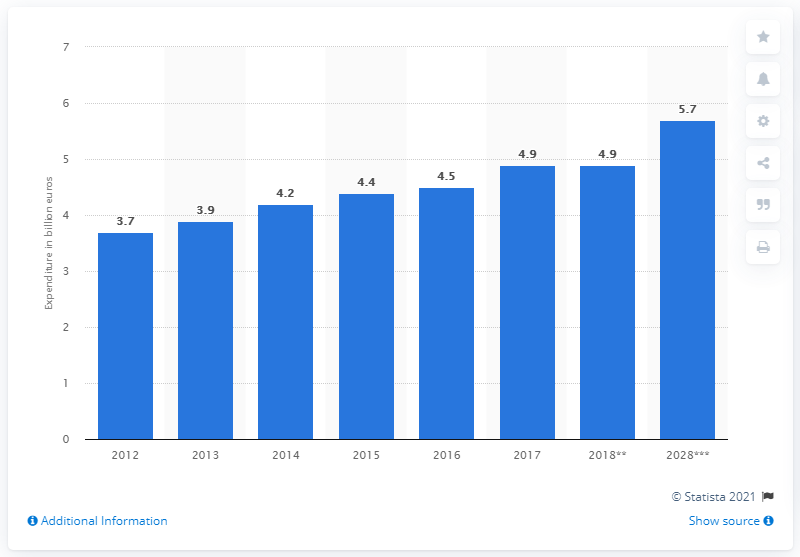Mention a couple of crucial points in this snapshot. According to estimates, Portugal's outbound travel spending in 2018 was approximately 4.9 billion U.S. dollars. Portugal's expected outbound travel spending in 2028 is forecasted to be approximately $5.7 billion. 